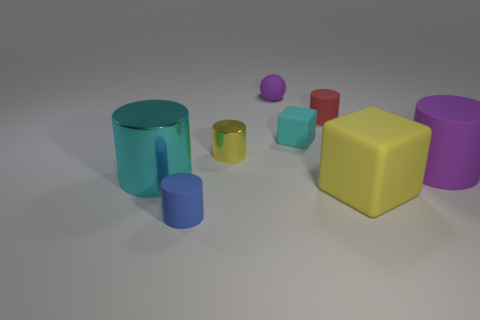What size is the matte thing that is the same color as the big metal cylinder?
Keep it short and to the point. Small. What number of objects are either small purple spheres or yellow objects that are in front of the yellow cylinder?
Keep it short and to the point. 2. Is there another large block made of the same material as the cyan block?
Keep it short and to the point. Yes. How many rubber things are both left of the yellow cylinder and behind the purple matte cylinder?
Offer a terse response. 0. There is a purple thing to the left of the red rubber object; what is it made of?
Ensure brevity in your answer.  Rubber. There is a cyan object that is made of the same material as the tiny yellow object; what size is it?
Offer a terse response. Large. Are there any large blocks on the right side of the purple sphere?
Ensure brevity in your answer.  Yes. There is a purple thing that is the same shape as the blue object; what size is it?
Your response must be concise. Large. Does the tiny cube have the same color as the thing that is to the left of the small blue cylinder?
Your response must be concise. Yes. Is the large shiny thing the same color as the small matte block?
Offer a very short reply. Yes. 